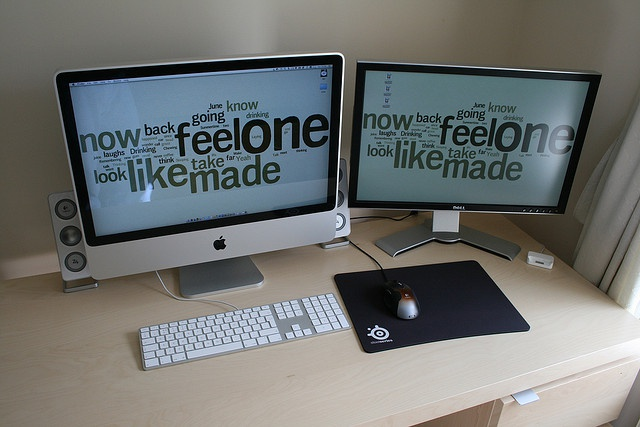Describe the objects in this image and their specific colors. I can see tv in gray, black, and darkgray tones, tv in gray and black tones, keyboard in gray, darkgray, lavender, and lightgray tones, and mouse in gray, black, and darkgray tones in this image. 